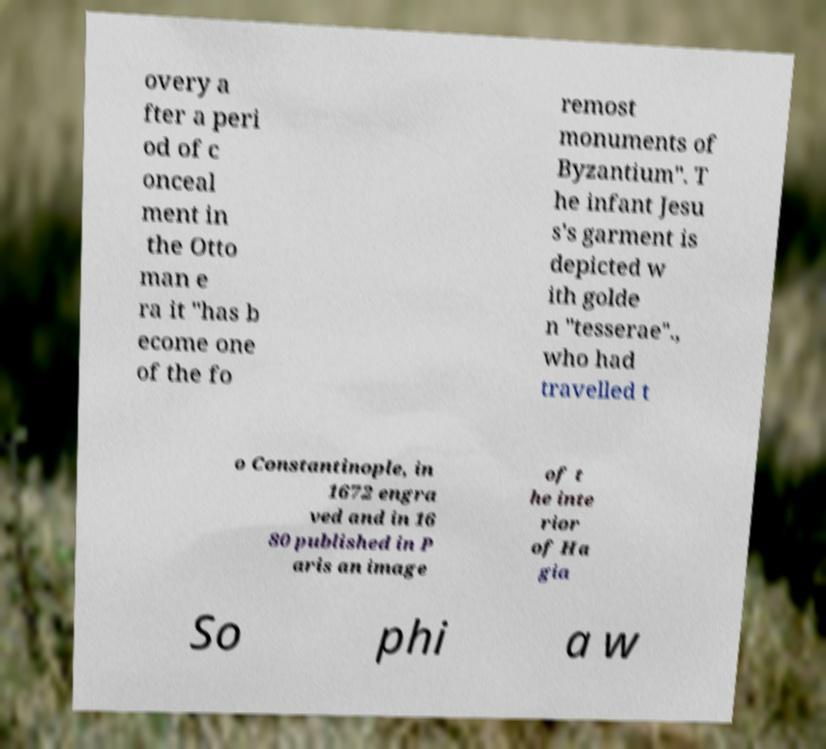What messages or text are displayed in this image? I need them in a readable, typed format. overy a fter a peri od of c onceal ment in the Otto man e ra it "has b ecome one of the fo remost monuments of Byzantium". T he infant Jesu s's garment is depicted w ith golde n "tesserae"., who had travelled t o Constantinople, in 1672 engra ved and in 16 80 published in P aris an image of t he inte rior of Ha gia So phi a w 